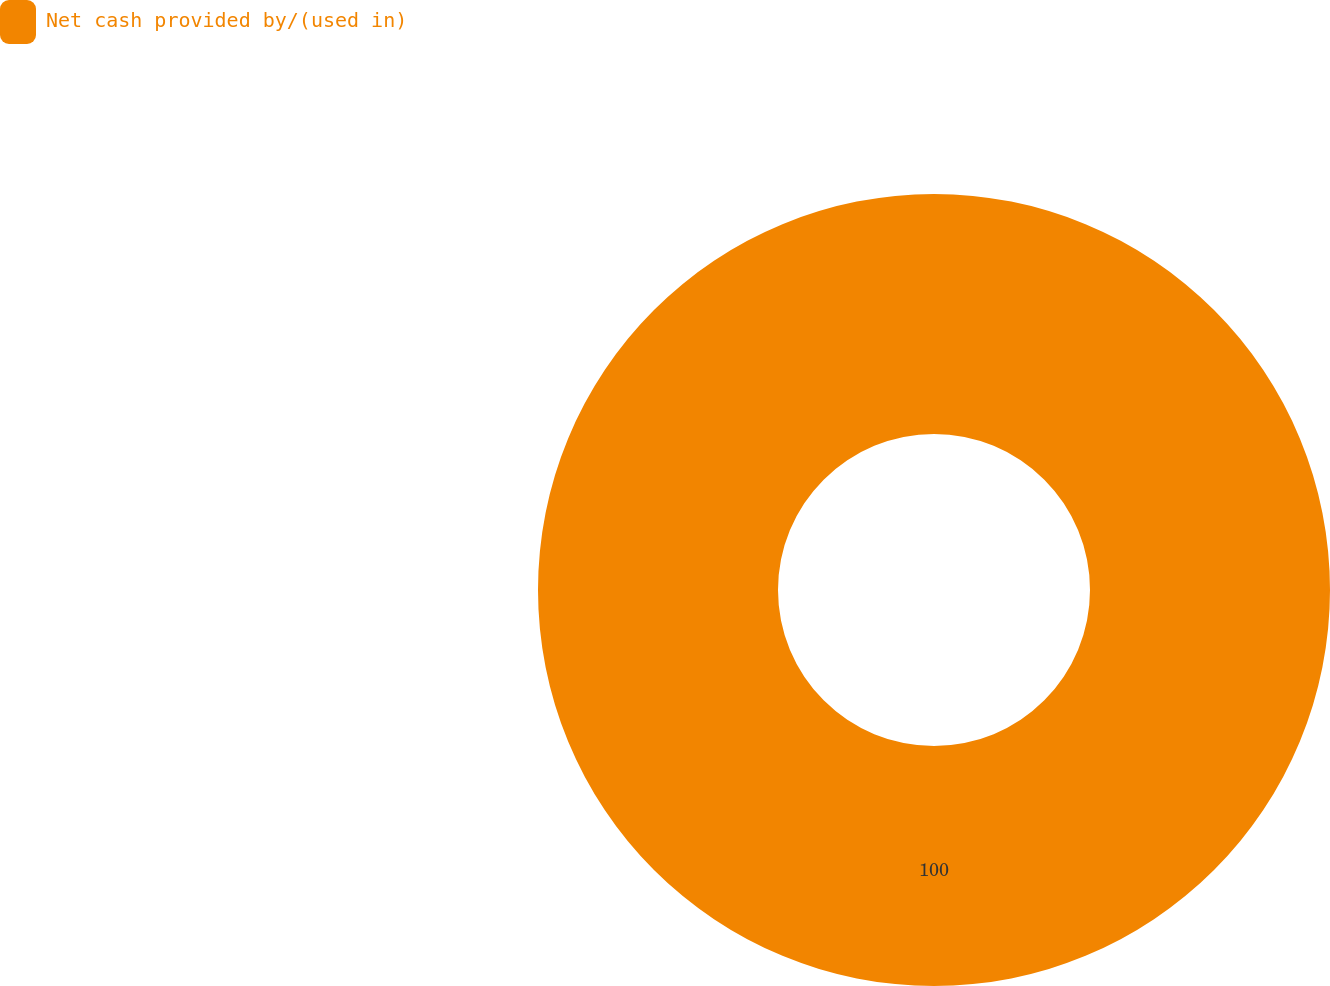<chart> <loc_0><loc_0><loc_500><loc_500><pie_chart><fcel>Net cash provided by/(used in)<nl><fcel>100.0%<nl></chart> 